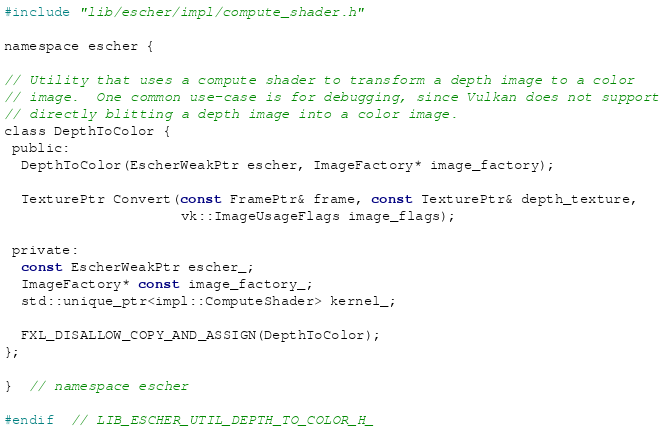<code> <loc_0><loc_0><loc_500><loc_500><_C_>#include "lib/escher/impl/compute_shader.h"

namespace escher {

// Utility that uses a compute shader to transform a depth image to a color
// image.  One common use-case is for debugging, since Vulkan does not support
// directly blitting a depth image into a color image.
class DepthToColor {
 public:
  DepthToColor(EscherWeakPtr escher, ImageFactory* image_factory);

  TexturePtr Convert(const FramePtr& frame, const TexturePtr& depth_texture,
                     vk::ImageUsageFlags image_flags);

 private:
  const EscherWeakPtr escher_;
  ImageFactory* const image_factory_;
  std::unique_ptr<impl::ComputeShader> kernel_;

  FXL_DISALLOW_COPY_AND_ASSIGN(DepthToColor);
};

}  // namespace escher

#endif  // LIB_ESCHER_UTIL_DEPTH_TO_COLOR_H_
</code> 